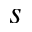<formula> <loc_0><loc_0><loc_500><loc_500>s</formula> 